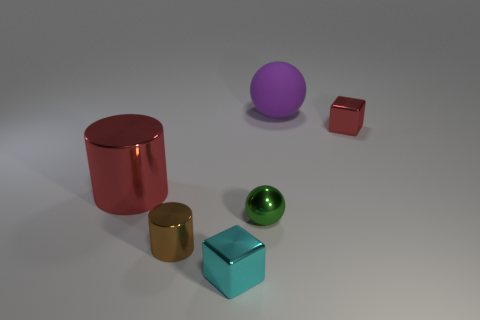Add 3 blue matte cylinders. How many objects exist? 9 Subtract all large rubber balls. Subtract all cyan shiny objects. How many objects are left? 4 Add 1 tiny cyan objects. How many tiny cyan objects are left? 2 Add 1 green matte cubes. How many green matte cubes exist? 1 Subtract 0 blue cylinders. How many objects are left? 6 Subtract all cylinders. How many objects are left? 4 